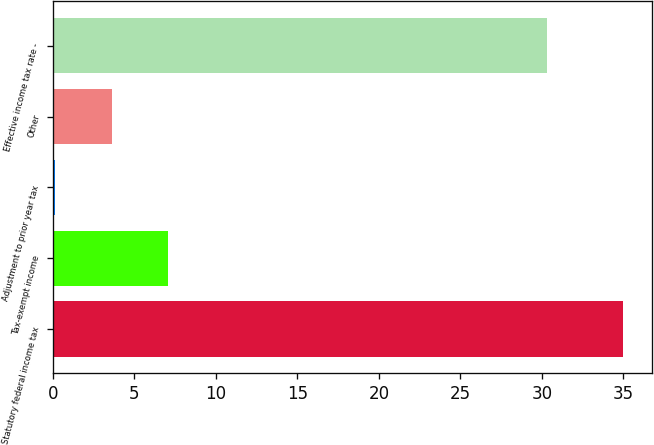<chart> <loc_0><loc_0><loc_500><loc_500><bar_chart><fcel>Statutory federal income tax<fcel>Tax-exempt income<fcel>Adjustment to prior year tax<fcel>Other<fcel>Effective income tax rate -<nl><fcel>35<fcel>7.08<fcel>0.1<fcel>3.59<fcel>30.3<nl></chart> 